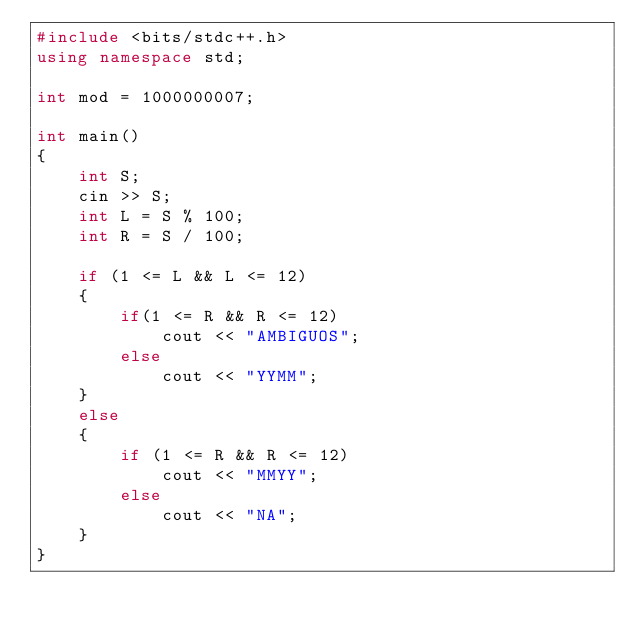Convert code to text. <code><loc_0><loc_0><loc_500><loc_500><_C++_>#include <bits/stdc++.h>
using namespace std;

int mod = 1000000007;

int main()
{
    int S;
    cin >> S;
    int L = S % 100;
    int R = S / 100;

    if (1 <= L && L <= 12)
    {
        if(1 <= R && R <= 12)
            cout << "AMBIGUOS";
        else
            cout << "YYMM";
    }
    else
    {
        if (1 <= R && R <= 12)
            cout << "MMYY";
        else
            cout << "NA";
    }
}</code> 